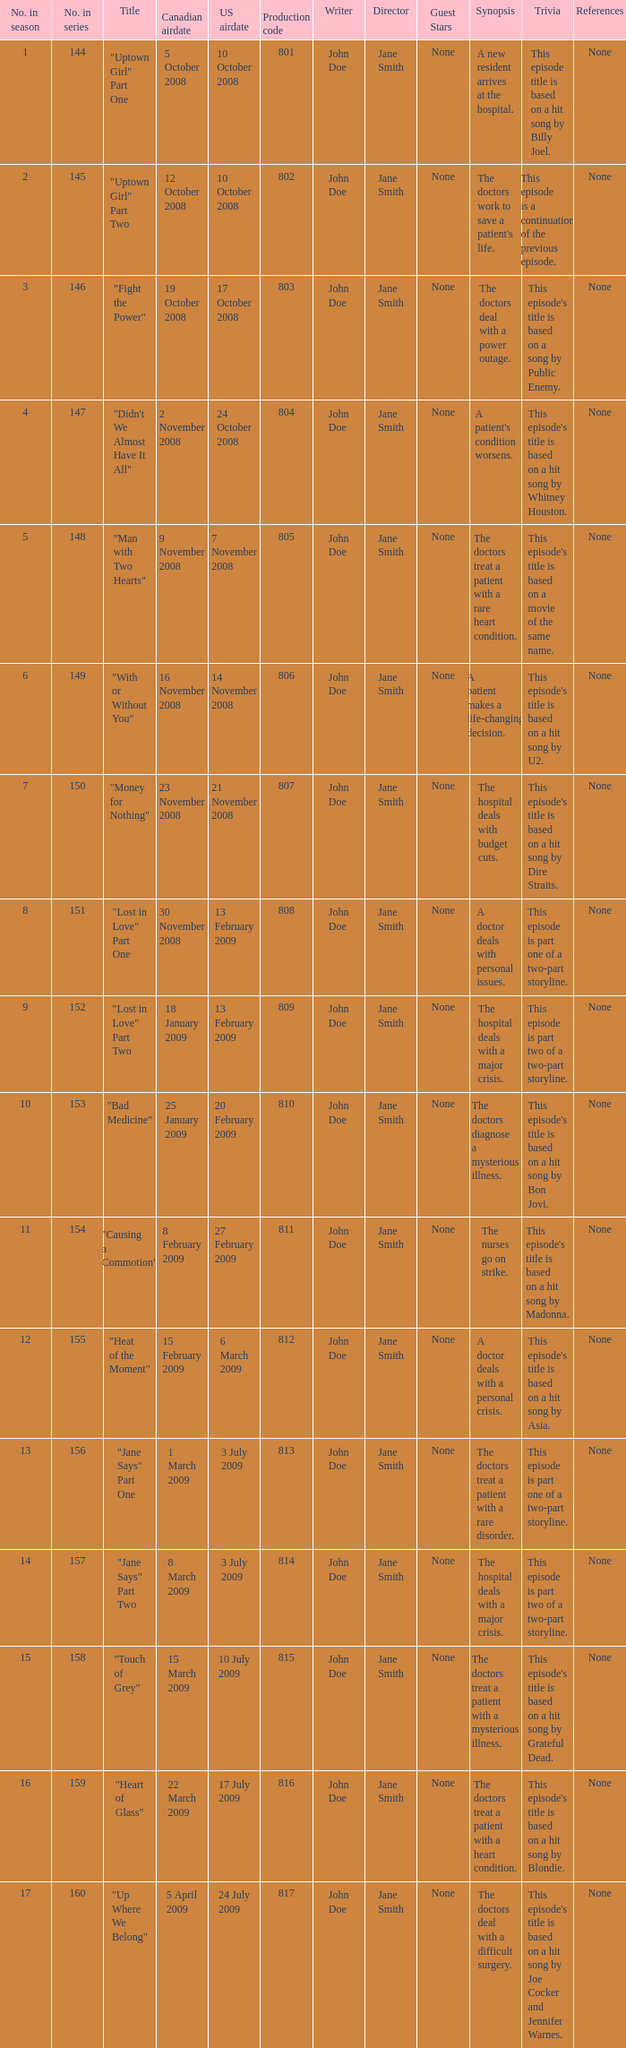How many U.S. air dates were from an episode in Season 4? 1.0. 